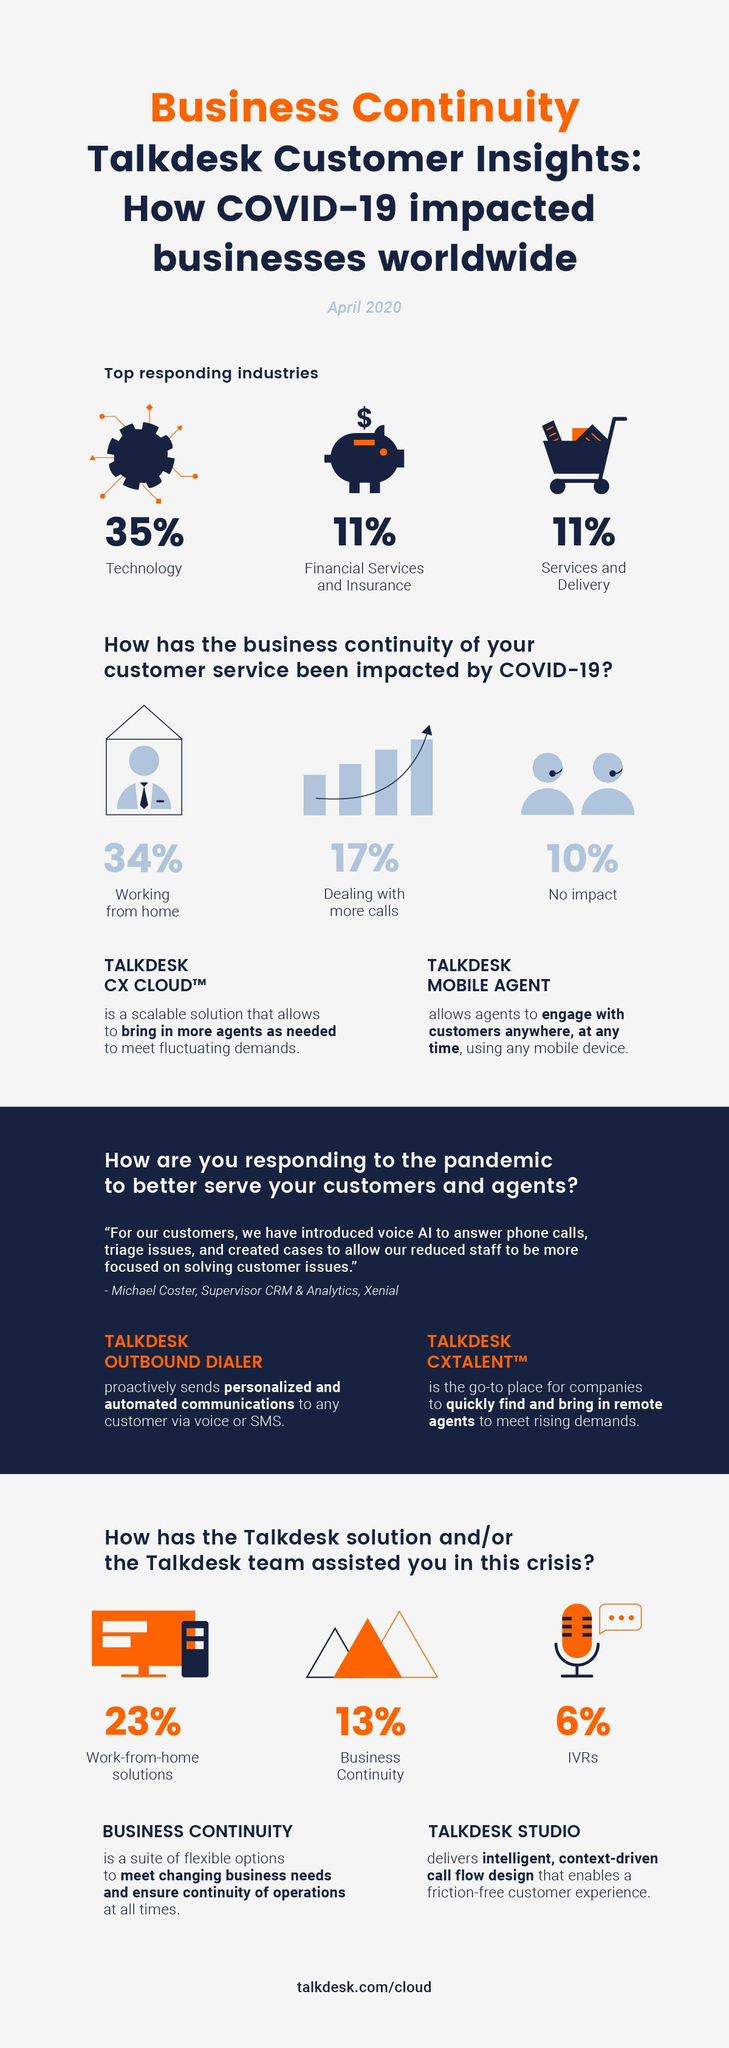Indicate a few pertinent items in this graphic. The main heading is written in a combination of black and blue or blue and orange. According to the data, only 33% of employees are working from home. The technology, financial services and insurance, services and delivery industries are the top responding industries to the proposed changes. Ninety percent of the business continuity of customer service has been impacted. The infographic represents the services and delivery industry with a cart symbol. 